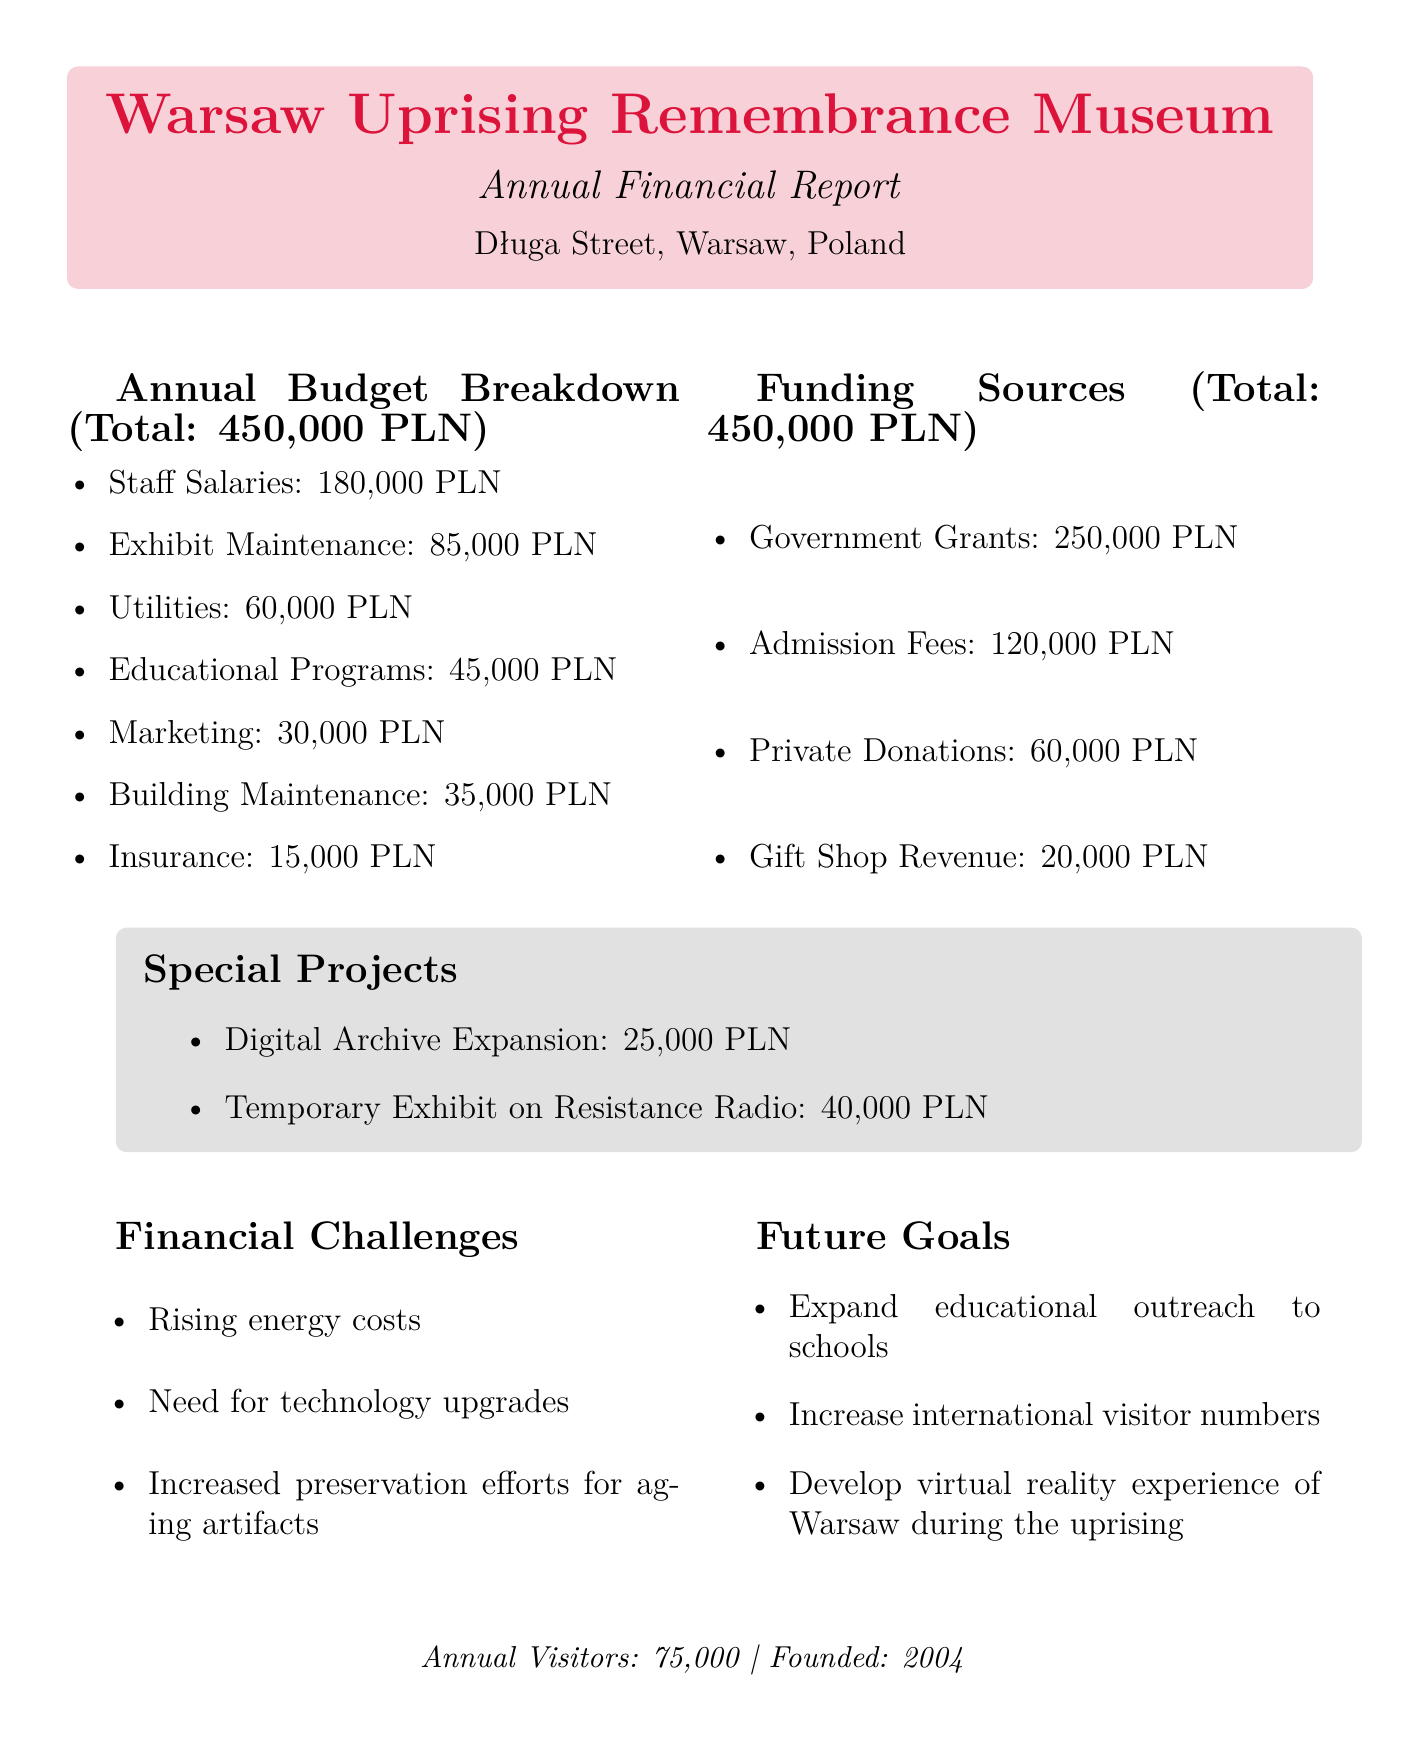What is the total budget? The total budget is mentioned explicitly in the document as 450,000 PLN.
Answer: 450,000 PLN How much is allocated for staff salaries? The document specifies that staff salaries receive 180,000 PLN of the budget allocation.
Answer: 180,000 PLN What is the funding source with the highest amount? According to the document, government grants provide the largest funding source at 250,000 PLN.
Answer: Government Grants How many annual visitors does the museum have? The document states that the museum sees 75,000 annual visitors as a key metric.
Answer: 75,000 What special project costs 40,000 PLN? The document lists the temporary exhibit on resistance radio as the special project costing 40,000 PLN.
Answer: Temporary Exhibit on Resistance Radio What are one of the financial challenges faced by the museum? The document outlines several challenges, one being "Rising energy costs."
Answer: Rising energy costs What is one future goal mentioned in the report? The document highlights "Expand educational outreach to schools" as one of the future goals.
Answer: Expand educational outreach to schools How much is allocated for exhibit maintenance? The document notes that exhibit maintenance is allocated 85,000 PLN from the budget.
Answer: 85,000 PLN What is the total amount generated from admission fees? The document indicates that the admission fees contribute 120,000 PLN to the funding sources.
Answer: 120,000 PLN 